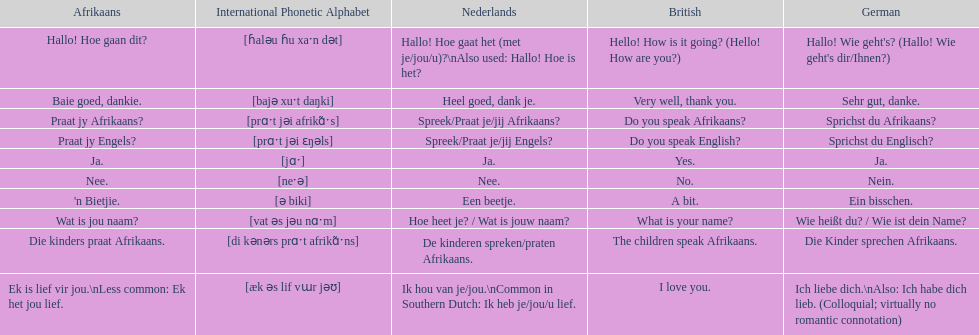How do you say 'i love you' in afrikaans? Ek is lief vir jou. Could you help me parse every detail presented in this table? {'header': ['Afrikaans', 'International Phonetic Alphabet', 'Nederlands', 'British', 'German'], 'rows': [['Hallo! Hoe gaan dit?', '[ɦaləu ɦu xaˑn dət]', 'Hallo! Hoe gaat het (met je/jou/u)?\\nAlso used: Hallo! Hoe is het?', 'Hello! How is it going? (Hello! How are you?)', "Hallo! Wie geht's? (Hallo! Wie geht's dir/Ihnen?)"], ['Baie goed, dankie.', '[bajə xuˑt daŋki]', 'Heel goed, dank je.', 'Very well, thank you.', 'Sehr gut, danke.'], ['Praat jy Afrikaans?', '[prɑˑt jəi afrikɑ̃ˑs]', 'Spreek/Praat je/jij Afrikaans?', 'Do you speak Afrikaans?', 'Sprichst du Afrikaans?'], ['Praat jy Engels?', '[prɑˑt jəi ɛŋəls]', 'Spreek/Praat je/jij Engels?', 'Do you speak English?', 'Sprichst du Englisch?'], ['Ja.', '[jɑˑ]', 'Ja.', 'Yes.', 'Ja.'], ['Nee.', '[neˑə]', 'Nee.', 'No.', 'Nein.'], ["'n Bietjie.", '[ə biki]', 'Een beetje.', 'A bit.', 'Ein bisschen.'], ['Wat is jou naam?', '[vat əs jəu nɑˑm]', 'Hoe heet je? / Wat is jouw naam?', 'What is your name?', 'Wie heißt du? / Wie ist dein Name?'], ['Die kinders praat Afrikaans.', '[di kənərs prɑˑt afrikɑ̃ˑns]', 'De kinderen spreken/praten Afrikaans.', 'The children speak Afrikaans.', 'Die Kinder sprechen Afrikaans.'], ['Ek is lief vir jou.\\nLess common: Ek het jou lief.', '[æk əs lif vɯr jəʊ]', 'Ik hou van je/jou.\\nCommon in Southern Dutch: Ik heb je/jou/u lief.', 'I love you.', 'Ich liebe dich.\\nAlso: Ich habe dich lieb. (Colloquial; virtually no romantic connotation)']]} 